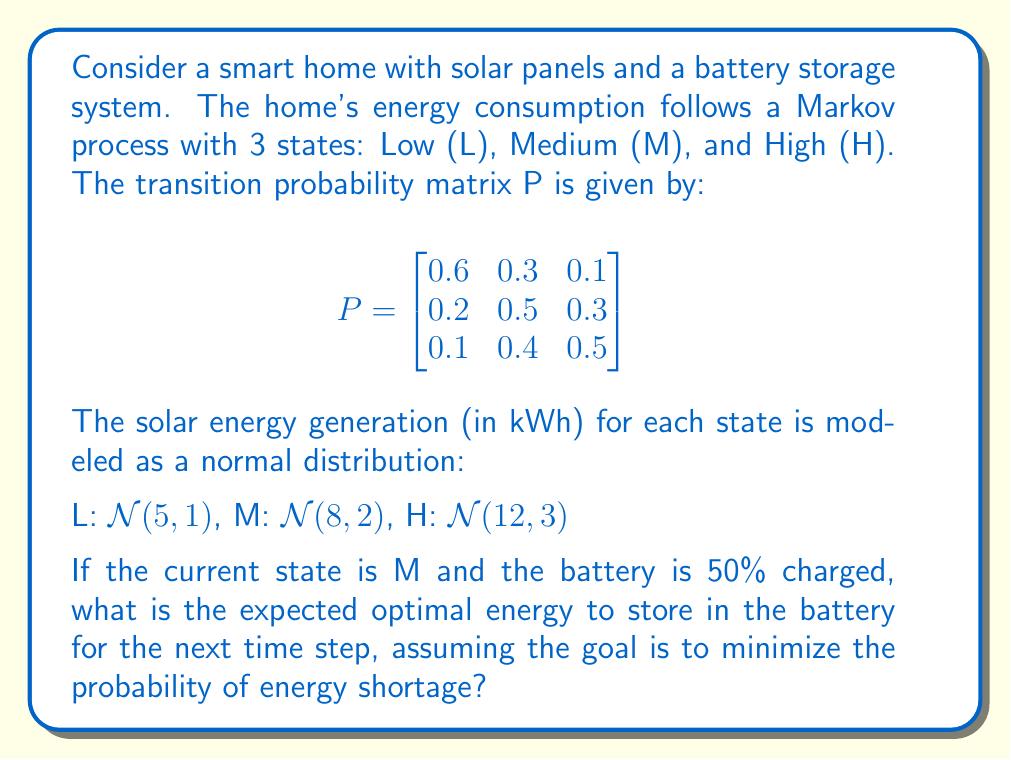Show me your answer to this math problem. To solve this problem, we'll use stochastic dynamic programming:

1) First, calculate the probability of transitioning to each state from M:
   P(L|M) = 0.2, P(M|M) = 0.5, P(H|M) = 0.3

2) Calculate the expected energy generation for each state:
   E(L) = 5 kWh, E(M) = 8 kWh, E(H) = 12 kWh

3) Calculate the expected energy generation for the next step:
   E(next) = 0.2 * 5 + 0.5 * 8 + 0.3 * 12 = 8.6 kWh

4) Assume the battery capacity is 10 kWh (typical for home systems). Current charge is 5 kWh (50%).

5) To minimize shortage risk, we should store the difference between expected generation and maximum capacity:
   Optimal storage = 10 - 8.6 = 1.4 kWh

6) However, we can only store up to the available capacity:
   Available capacity = 10 - 5 = 5 kWh

7) Therefore, the optimal energy to store is the minimum of steps 5 and 6:
   min(1.4, 5) = 1.4 kWh

This strategy ensures we have enough capacity to store excess energy in case of high generation while maintaining a buffer for potential high consumption periods.
Answer: 1.4 kWh 